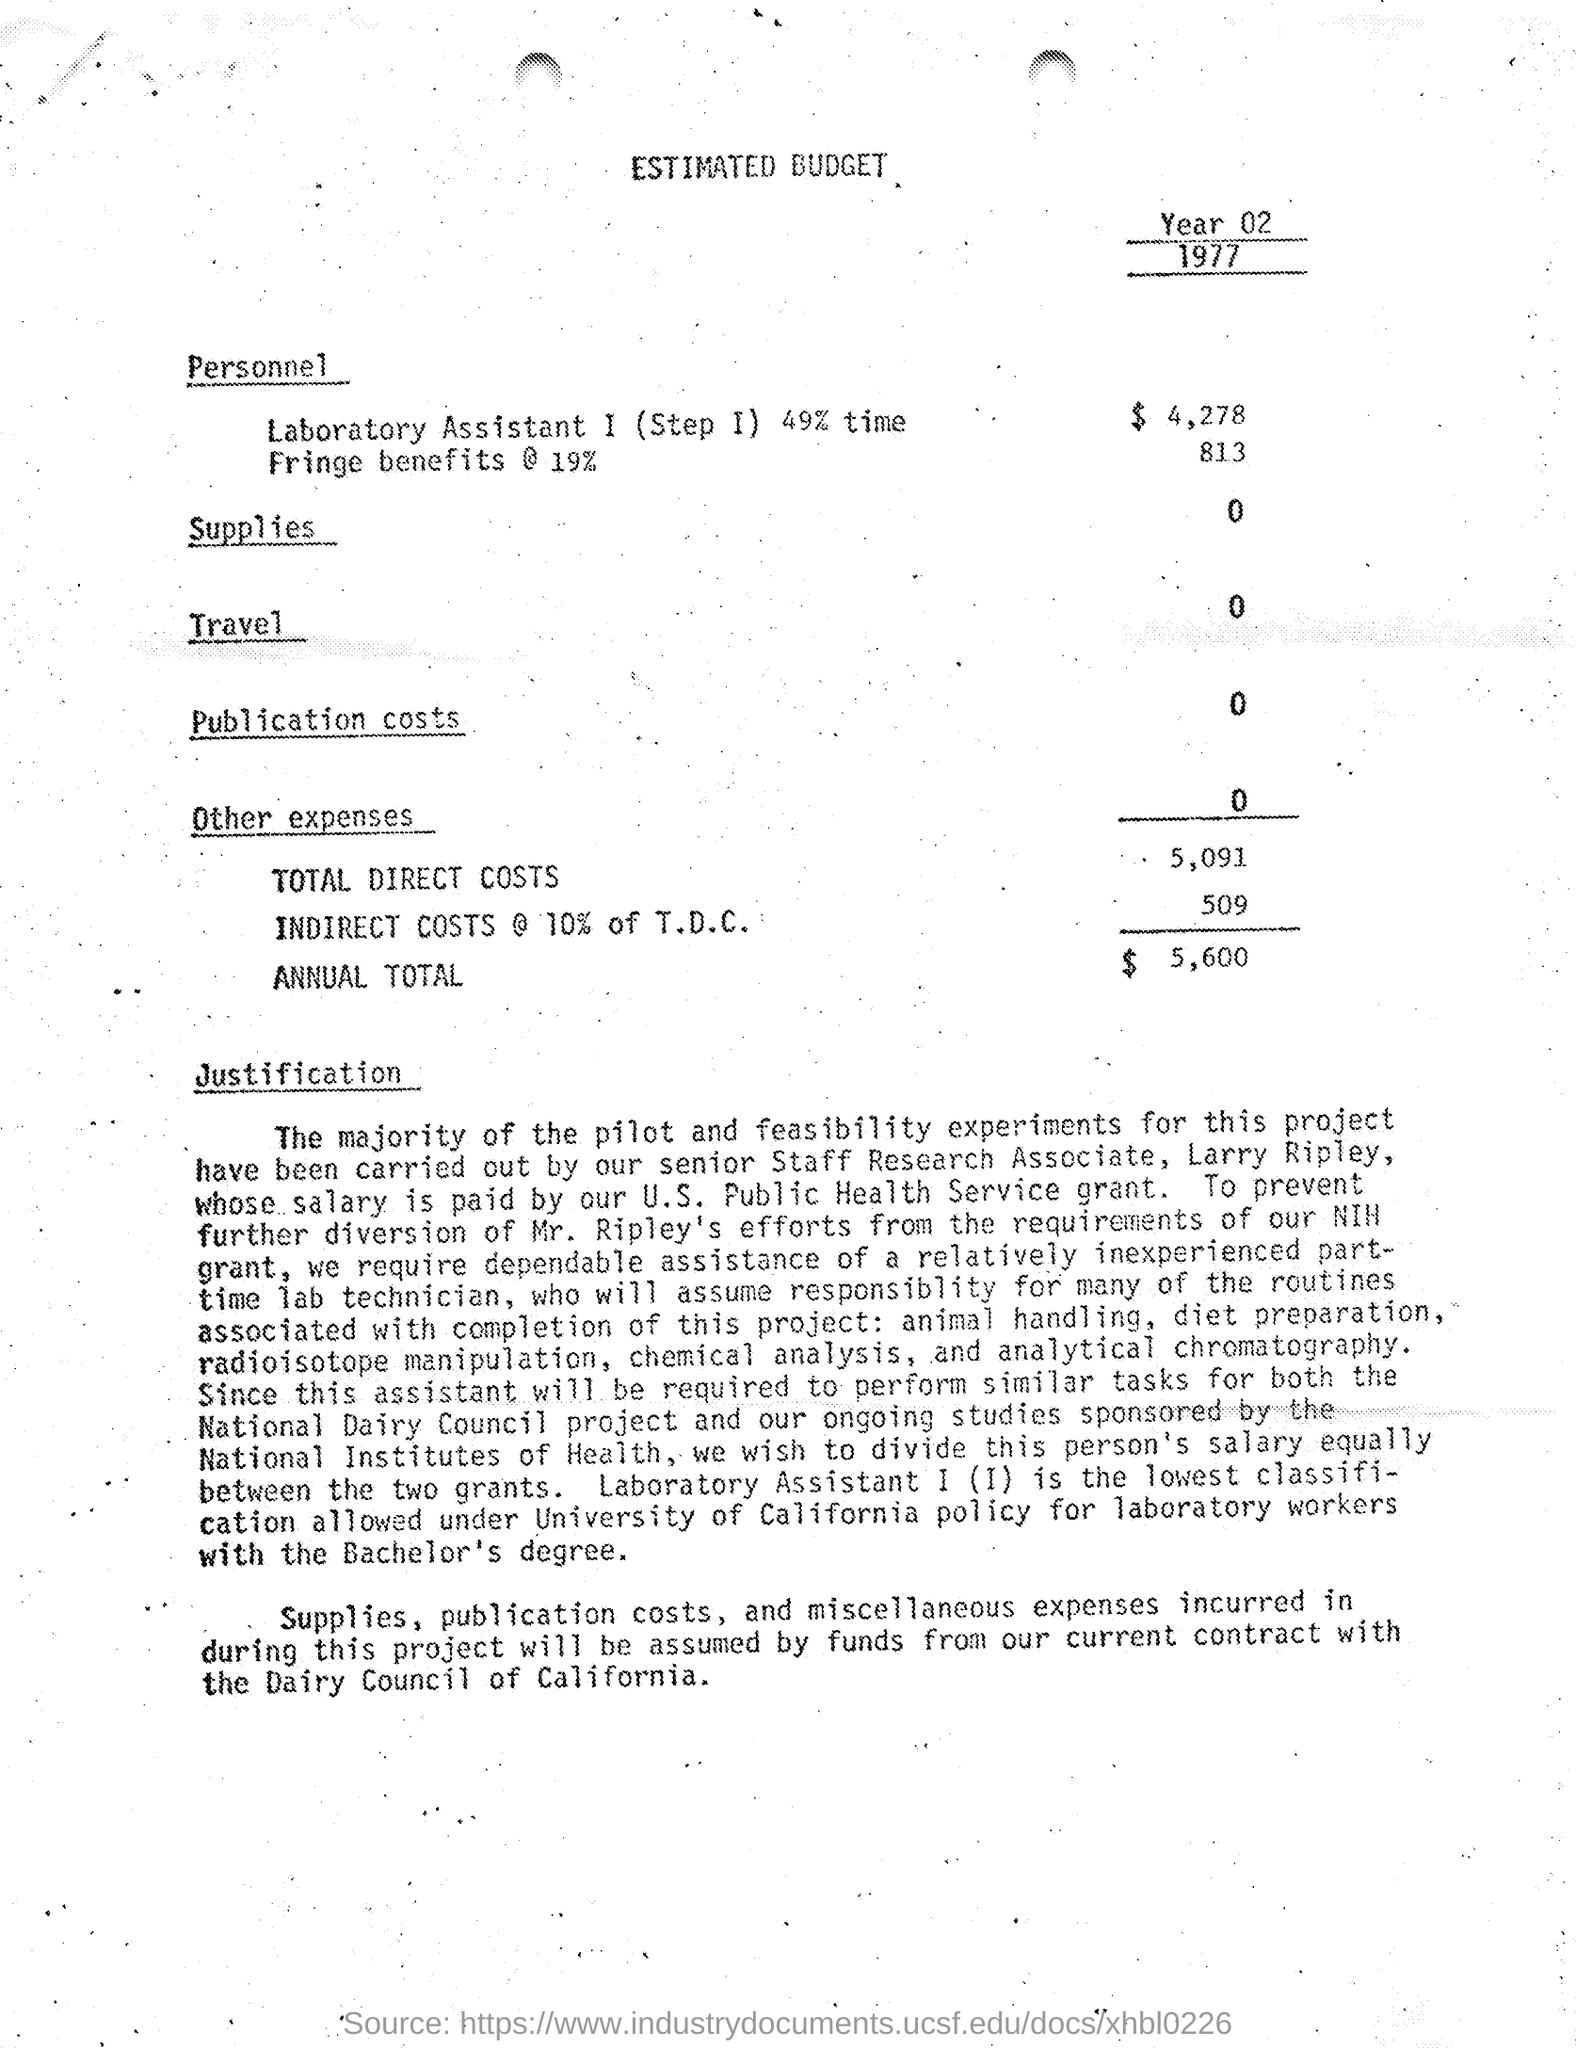What kind of expenses are covered under 'Other expenses'? The 'Other expenses' category is listed but shows an allocation of $0, which means that either there were no expenses categorized as such for this budget or they are included in other sections implicitly. 